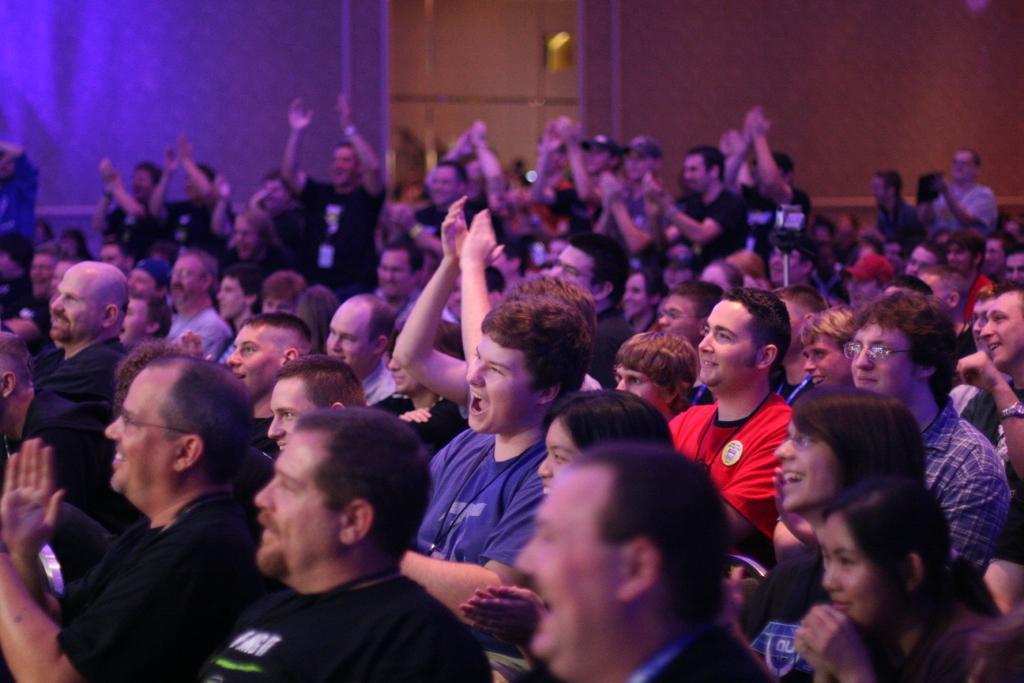In one or two sentences, can you explain what this image depicts? In this image, we can see a crowd and in the background, there is a wall. 